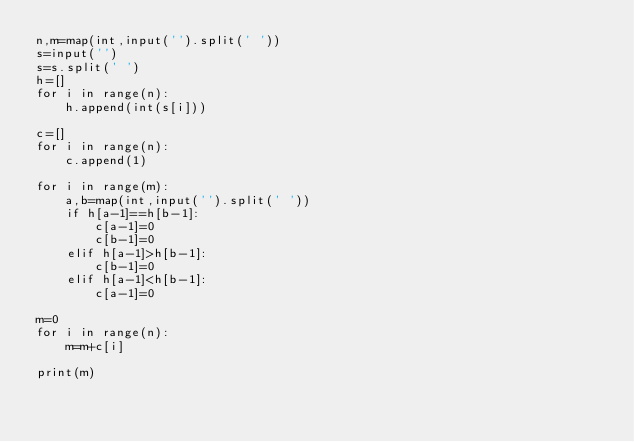Convert code to text. <code><loc_0><loc_0><loc_500><loc_500><_Python_>n,m=map(int,input('').split(' '))
s=input('')
s=s.split(' ')
h=[]
for i in range(n):
    h.append(int(s[i]))

c=[]
for i in range(n):
    c.append(1)

for i in range(m):
    a,b=map(int,input('').split(' '))
    if h[a-1]==h[b-1]:
        c[a-1]=0
        c[b-1]=0
    elif h[a-1]>h[b-1]:
        c[b-1]=0
    elif h[a-1]<h[b-1]:
        c[a-1]=0

m=0
for i in range(n):
    m=m+c[i]

print(m)</code> 